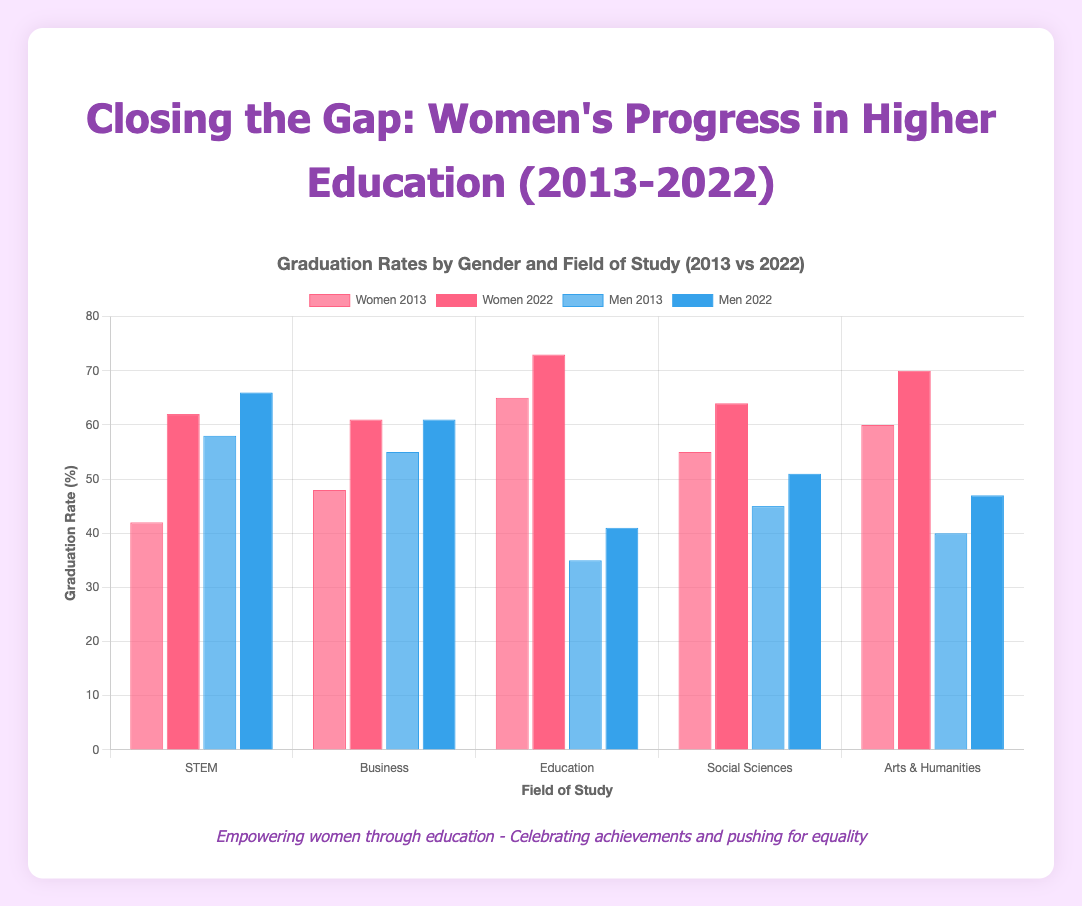What is the difference in the graduation rate of women in STEM between 2013 and 2022? The graduation rate for women in STEM in 2013 was 42% and in 2022 it was 62%. The difference can be calculated as 62% - 42% = 20%.
Answer: 20% Which field of study had the highest graduation rate for women in 2022? By examining the graduation rates for women in different fields of study in 2022, we can see that Education had the highest rate at 73%.
Answer: Education How much did the graduation rate for men in Business change from 2013 to 2022? The graduation rate for men in Business in 2013 was 55% and in 2022 it was 61%. The change can be calculated as 61% - 55% = 6%.
Answer: 6% Which field of study had the smallest difference in graduation rates between men and women in 2013? By comparing the differences in graduation rates between men and women in 2013 across all fields, STEM had the smallest difference with a gap of 16% (58% for men and 42% for women).
Answer: STEM In 2022, in which field of study did women surpass men in graduation rates, and by how much? By comparing the graduation rates of men and women in 2022, women surpassed men in Business by 0% both at 61%, Education by 32% (73% for women and 41% for men), Social Sciences by 13% (64% for women and 51% for men), and Arts & Humanities by 23% (70% for women and 47% for men). The largest difference was in Education with a gap of 32%.
Answer: Education, 32% What trend do you observe in the graduation rates of women in STEM from 2013 to 2022? Observing the graduation rates of women in STEM from 2013 to 2022, there is a clear upward trend where the rates increased from 42% in 2013 to 62% in 2022. This shows continuous improvement in the graduation rates of women in STEM over the decade.
Answer: Upward trend Which field of study had the most significant improvement in graduation rates for women from 2013 to 2022? By calculating the difference in graduation rates for women from 2013 to 2022 across all fields, STEM shows a significant improvement with an increase of 20%.
Answer: STEM In 2013, which field had the largest gap between male and female graduation rates? In 2013, the field of Education had the largest gap with a difference of 30% (35% for men and 65% for women).
Answer: Education 